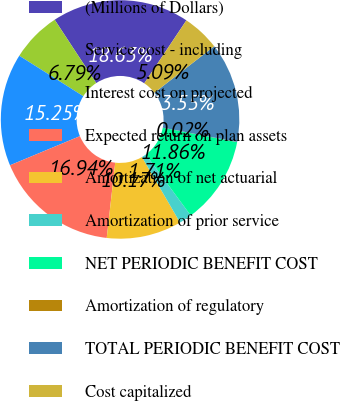Convert chart. <chart><loc_0><loc_0><loc_500><loc_500><pie_chart><fcel>(Millions of Dollars)<fcel>Service cost - including<fcel>Interest cost on projected<fcel>Expected return on plan assets<fcel>Amortization of net actuarial<fcel>Amortization of prior service<fcel>NET PERIODIC BENEFIT COST<fcel>Amortization of regulatory<fcel>TOTAL PERIODIC BENEFIT COST<fcel>Cost capitalized<nl><fcel>18.63%<fcel>6.79%<fcel>15.25%<fcel>16.94%<fcel>10.17%<fcel>1.71%<fcel>11.86%<fcel>0.02%<fcel>13.55%<fcel>5.09%<nl></chart> 